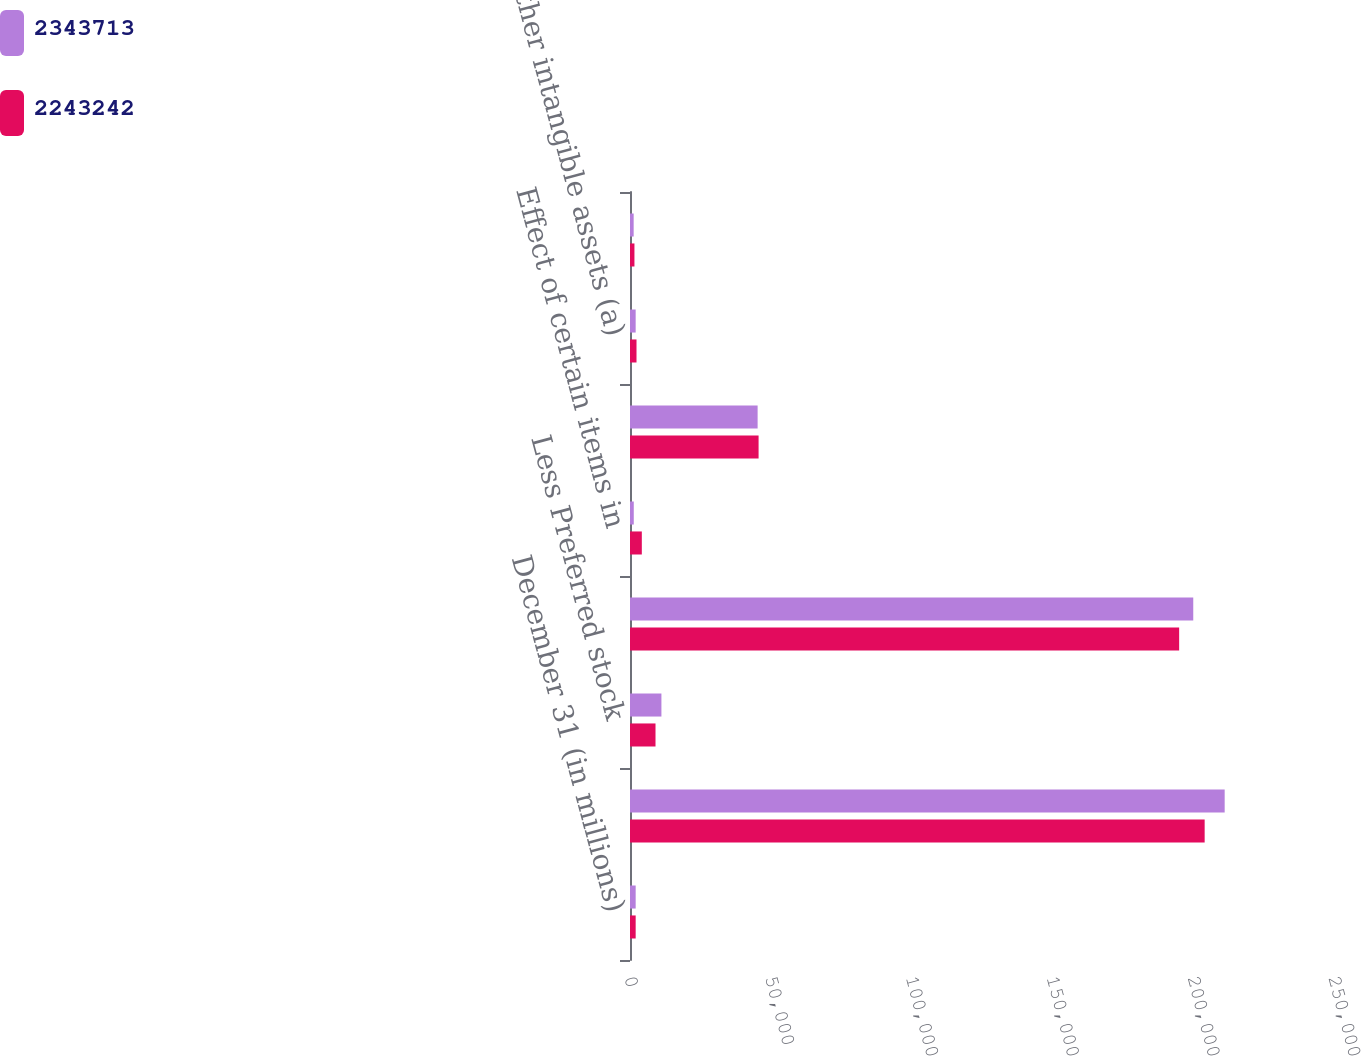Convert chart. <chart><loc_0><loc_0><loc_500><loc_500><stacked_bar_chart><ecel><fcel>December 31 (in millions)<fcel>Total stockholders' equity<fcel>Less Preferred stock<fcel>Common stockholders' equity<fcel>Effect of certain items in<fcel>Less Goodwill (a)<fcel>Other intangible assets (a)<fcel>Fair value DVA on structured<nl><fcel>2.34371e+06<fcel>2013<fcel>211178<fcel>11158<fcel>200020<fcel>1337<fcel>45320<fcel>2012<fcel>1300<nl><fcel>2.24324e+06<fcel>2012<fcel>204069<fcel>9058<fcel>195011<fcel>4198<fcel>45663<fcel>2311<fcel>1577<nl></chart> 